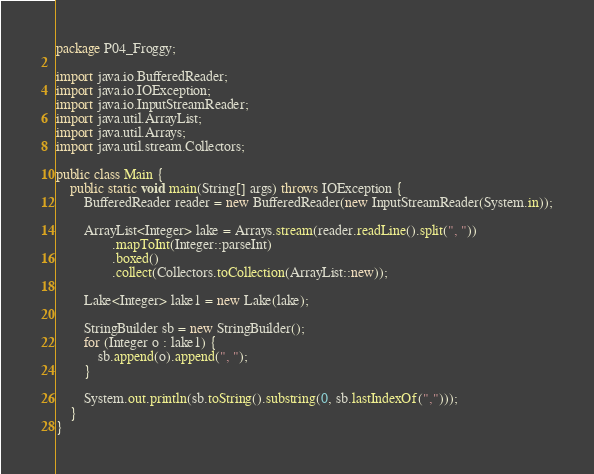<code> <loc_0><loc_0><loc_500><loc_500><_Java_>package P04_Froggy;

import java.io.BufferedReader;
import java.io.IOException;
import java.io.InputStreamReader;
import java.util.ArrayList;
import java.util.Arrays;
import java.util.stream.Collectors;

public class Main {
    public static void main(String[] args) throws IOException {
        BufferedReader reader = new BufferedReader(new InputStreamReader(System.in));

        ArrayList<Integer> lake = Arrays.stream(reader.readLine().split(", "))
                .mapToInt(Integer::parseInt)
                .boxed()
                .collect(Collectors.toCollection(ArrayList::new));

        Lake<Integer> lake1 = new Lake(lake);

        StringBuilder sb = new StringBuilder();
        for (Integer o : lake1) {
            sb.append(o).append(", ");
        }

        System.out.println(sb.toString().substring(0, sb.lastIndexOf(",")));
    }
}
</code> 